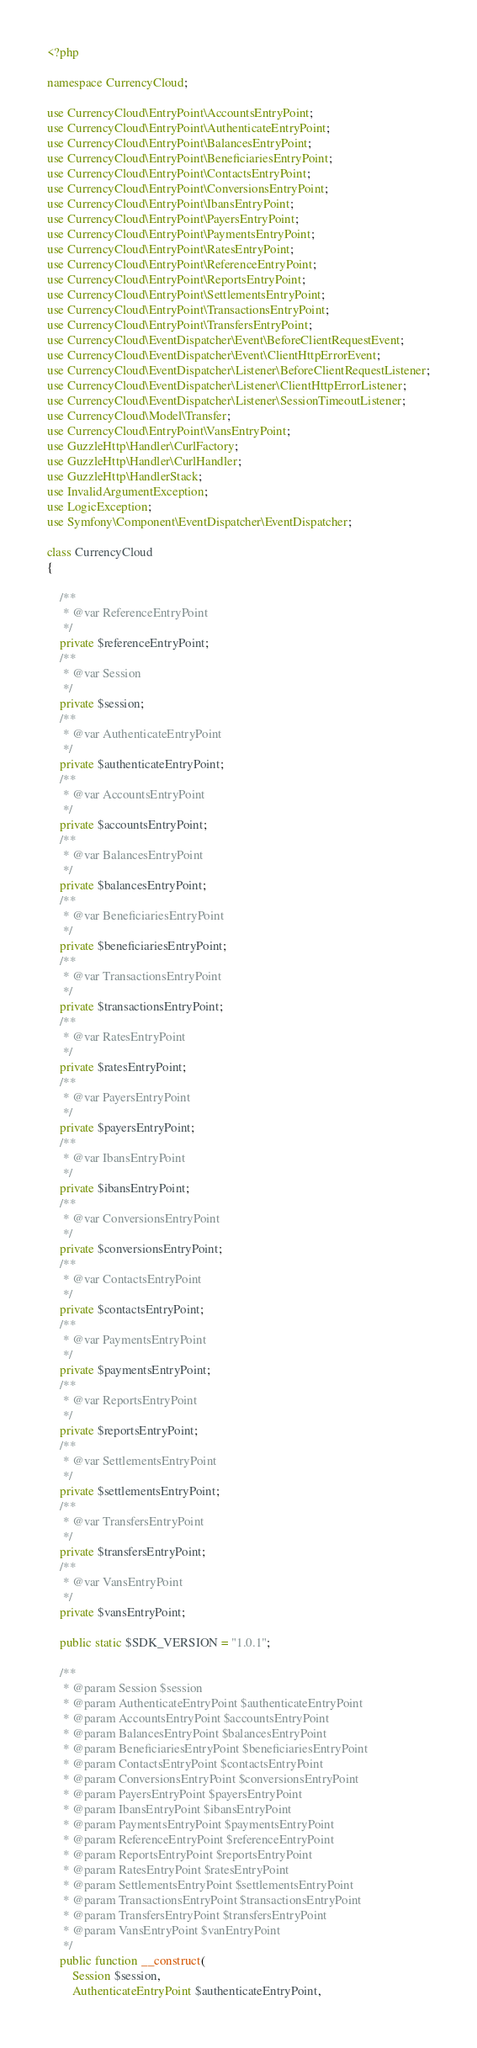Convert code to text. <code><loc_0><loc_0><loc_500><loc_500><_PHP_><?php

namespace CurrencyCloud;

use CurrencyCloud\EntryPoint\AccountsEntryPoint;
use CurrencyCloud\EntryPoint\AuthenticateEntryPoint;
use CurrencyCloud\EntryPoint\BalancesEntryPoint;
use CurrencyCloud\EntryPoint\BeneficiariesEntryPoint;
use CurrencyCloud\EntryPoint\ContactsEntryPoint;
use CurrencyCloud\EntryPoint\ConversionsEntryPoint;
use CurrencyCloud\EntryPoint\IbansEntryPoint;
use CurrencyCloud\EntryPoint\PayersEntryPoint;
use CurrencyCloud\EntryPoint\PaymentsEntryPoint;
use CurrencyCloud\EntryPoint\RatesEntryPoint;
use CurrencyCloud\EntryPoint\ReferenceEntryPoint;
use CurrencyCloud\EntryPoint\ReportsEntryPoint;
use CurrencyCloud\EntryPoint\SettlementsEntryPoint;
use CurrencyCloud\EntryPoint\TransactionsEntryPoint;
use CurrencyCloud\EntryPoint\TransfersEntryPoint;
use CurrencyCloud\EventDispatcher\Event\BeforeClientRequestEvent;
use CurrencyCloud\EventDispatcher\Event\ClientHttpErrorEvent;
use CurrencyCloud\EventDispatcher\Listener\BeforeClientRequestListener;
use CurrencyCloud\EventDispatcher\Listener\ClientHttpErrorListener;
use CurrencyCloud\EventDispatcher\Listener\SessionTimeoutListener;
use CurrencyCloud\Model\Transfer;
use CurrencyCloud\EntryPoint\VansEntryPoint;
use GuzzleHttp\Handler\CurlFactory;
use GuzzleHttp\Handler\CurlHandler;
use GuzzleHttp\HandlerStack;
use InvalidArgumentException;
use LogicException;
use Symfony\Component\EventDispatcher\EventDispatcher;

class CurrencyCloud
{

    /**
     * @var ReferenceEntryPoint
     */
    private $referenceEntryPoint;
    /**
     * @var Session
     */
    private $session;
    /**
     * @var AuthenticateEntryPoint
     */
    private $authenticateEntryPoint;
    /**
     * @var AccountsEntryPoint
     */
    private $accountsEntryPoint;
    /**
     * @var BalancesEntryPoint
     */
    private $balancesEntryPoint;
    /**
     * @var BeneficiariesEntryPoint
     */
    private $beneficiariesEntryPoint;
    /**
     * @var TransactionsEntryPoint
     */
    private $transactionsEntryPoint;
    /**
     * @var RatesEntryPoint
     */
    private $ratesEntryPoint;
    /**
     * @var PayersEntryPoint
     */
    private $payersEntryPoint;
    /**
     * @var IbansEntryPoint
     */
    private $ibansEntryPoint;
    /**
     * @var ConversionsEntryPoint
     */
    private $conversionsEntryPoint;
    /**
     * @var ContactsEntryPoint
     */
    private $contactsEntryPoint;
    /**
     * @var PaymentsEntryPoint
     */
    private $paymentsEntryPoint;
    /**
     * @var ReportsEntryPoint
     */
    private $reportsEntryPoint;
    /**
     * @var SettlementsEntryPoint
     */
    private $settlementsEntryPoint;
    /**
     * @var TransfersEntryPoint
     */
    private $transfersEntryPoint;
    /**
     * @var VansEntryPoint
     */
    private $vansEntryPoint;

    public static $SDK_VERSION = "1.0.1";

    /**
     * @param Session $session
     * @param AuthenticateEntryPoint $authenticateEntryPoint
     * @param AccountsEntryPoint $accountsEntryPoint
     * @param BalancesEntryPoint $balancesEntryPoint
     * @param BeneficiariesEntryPoint $beneficiariesEntryPoint
     * @param ContactsEntryPoint $contactsEntryPoint
     * @param ConversionsEntryPoint $conversionsEntryPoint
     * @param PayersEntryPoint $payersEntryPoint
     * @param IbansEntryPoint $ibansEntryPoint
     * @param PaymentsEntryPoint $paymentsEntryPoint
     * @param ReferenceEntryPoint $referenceEntryPoint
     * @param ReportsEntryPoint $reportsEntryPoint
     * @param RatesEntryPoint $ratesEntryPoint
     * @param SettlementsEntryPoint $settlementsEntryPoint
     * @param TransactionsEntryPoint $transactionsEntryPoint
     * @param TransfersEntryPoint $transfersEntryPoint
     * @param VansEntryPoint $vanEntryPoint
     */
    public function __construct(
        Session $session,
        AuthenticateEntryPoint $authenticateEntryPoint,</code> 